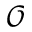Convert formula to latex. <formula><loc_0><loc_0><loc_500><loc_500>\mathcal { O }</formula> 